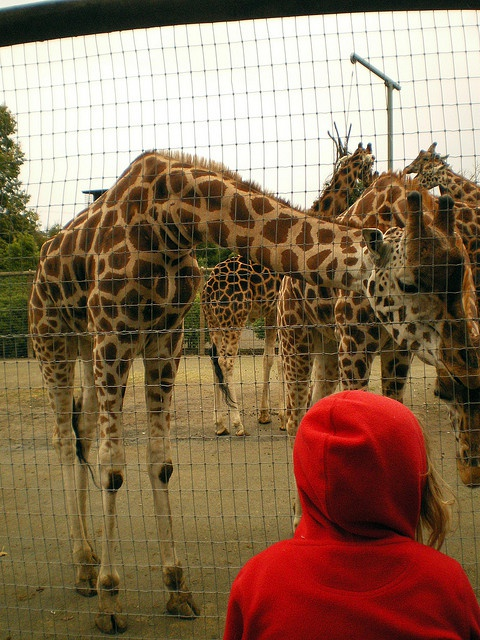Describe the objects in this image and their specific colors. I can see giraffe in ivory, olive, black, and maroon tones, people in ivory, maroon, red, and black tones, giraffe in ivory, black, olive, and maroon tones, giraffe in ivory, black, maroon, and brown tones, and giraffe in ivory, olive, maroon, and black tones in this image. 